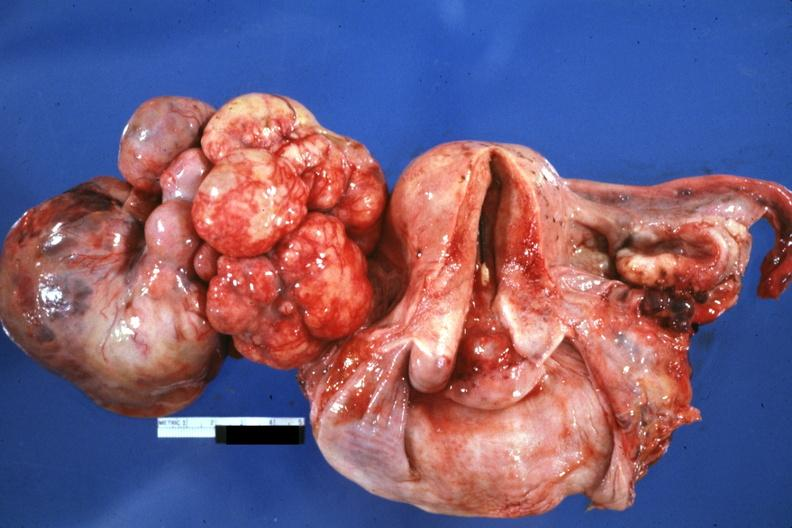what is present?
Answer the question using a single word or phrase. Metastatic carcinoma 